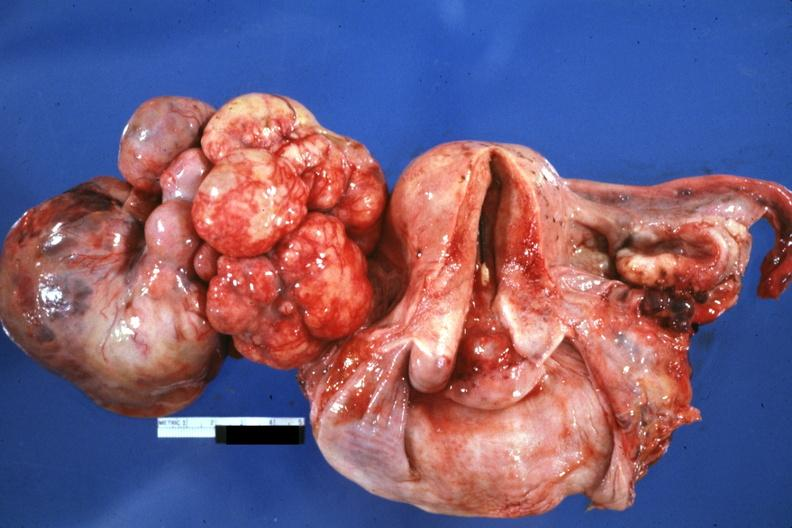what is present?
Answer the question using a single word or phrase. Metastatic carcinoma 